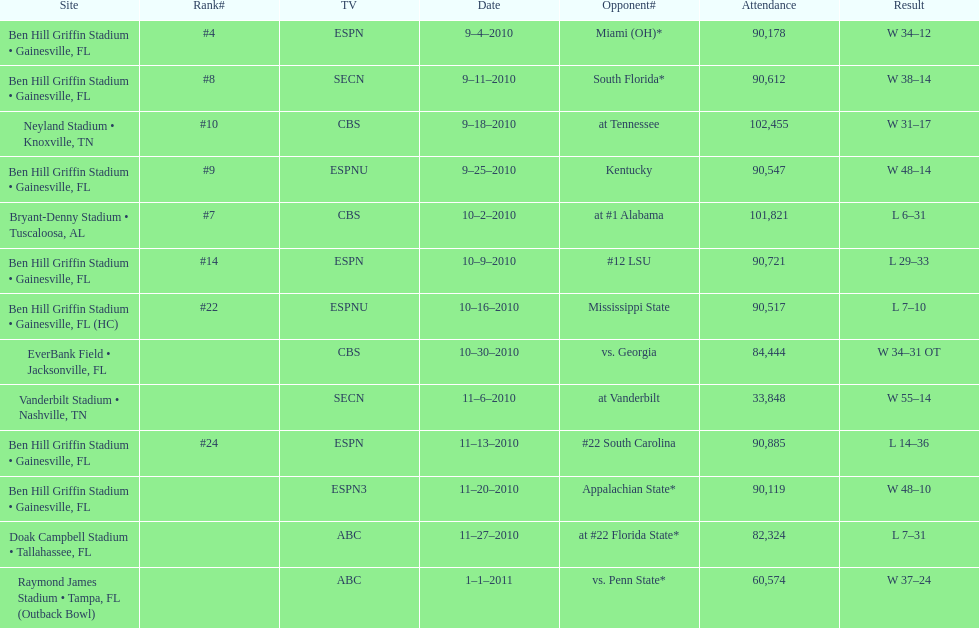What is the number of games played in teh 2010-2011 season 13. 